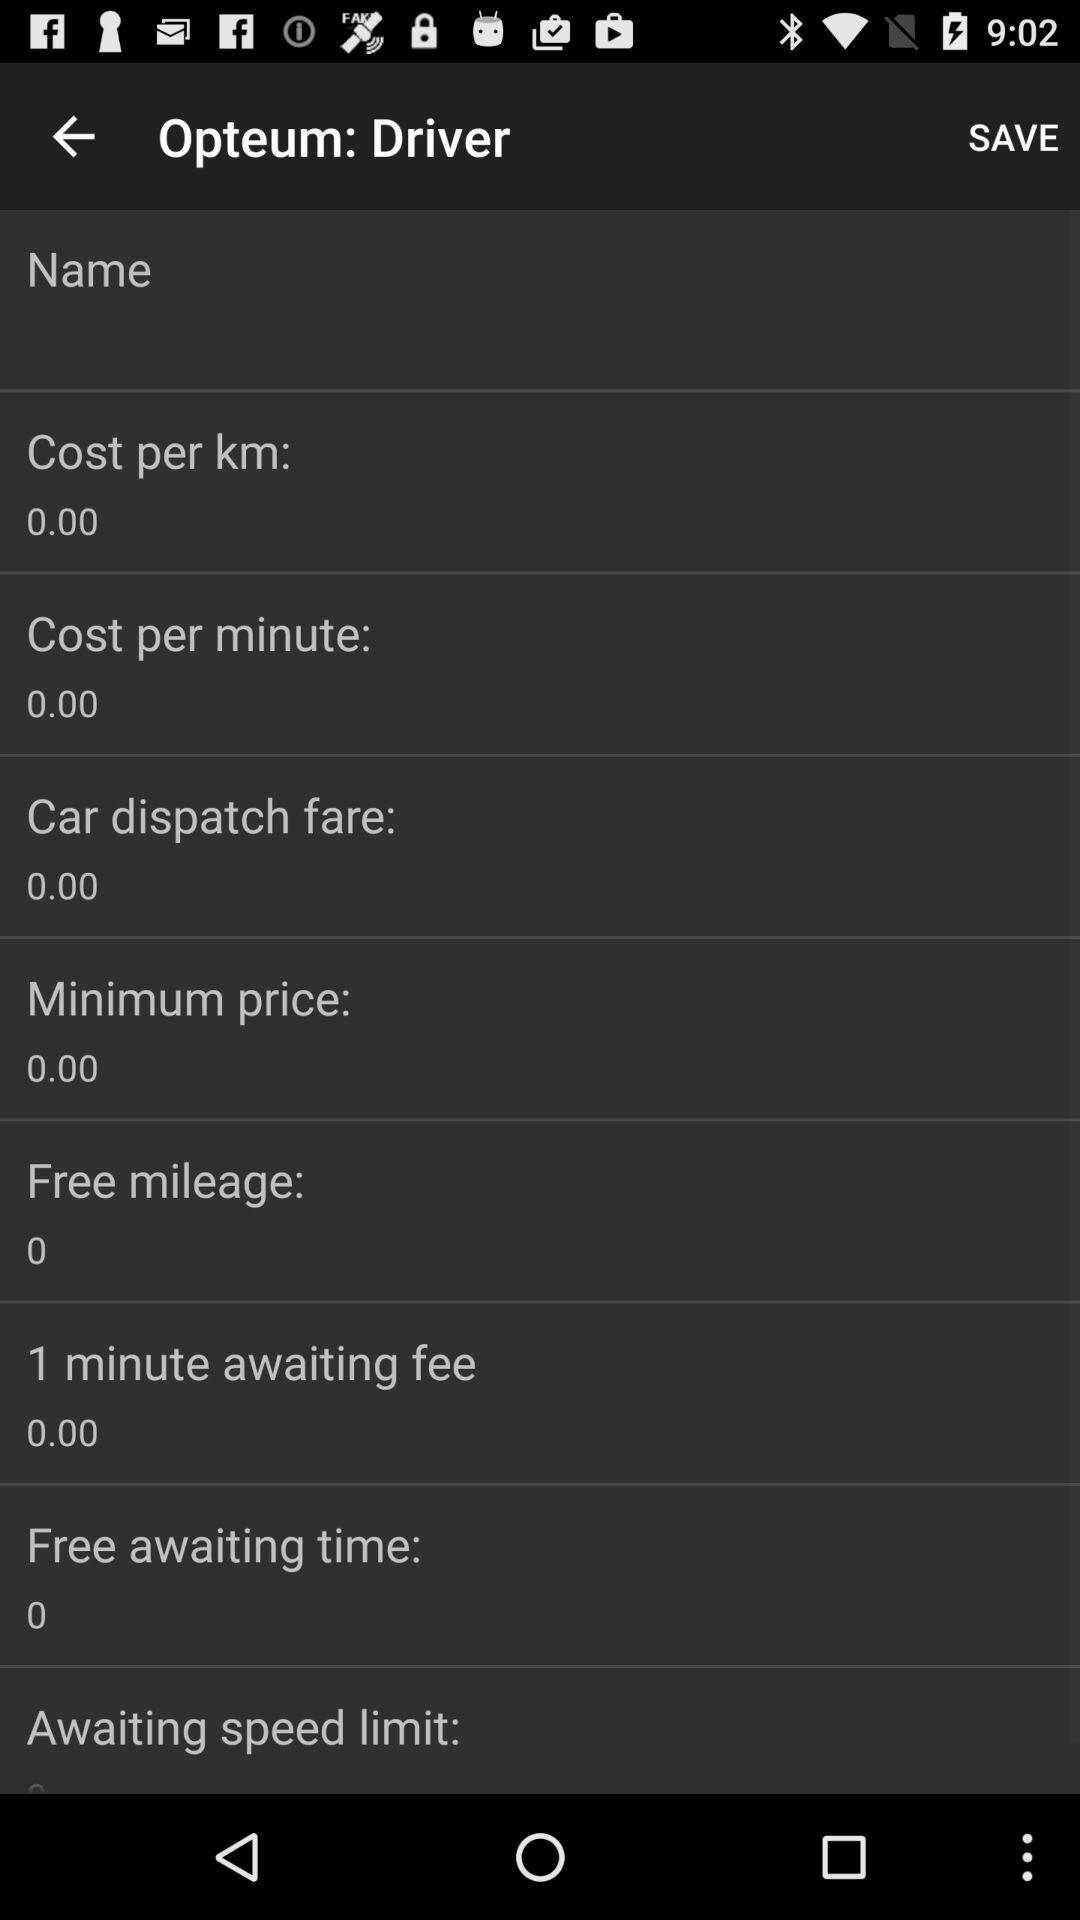How much free awaiting time is shown? The shown free awaiting time is 0. 